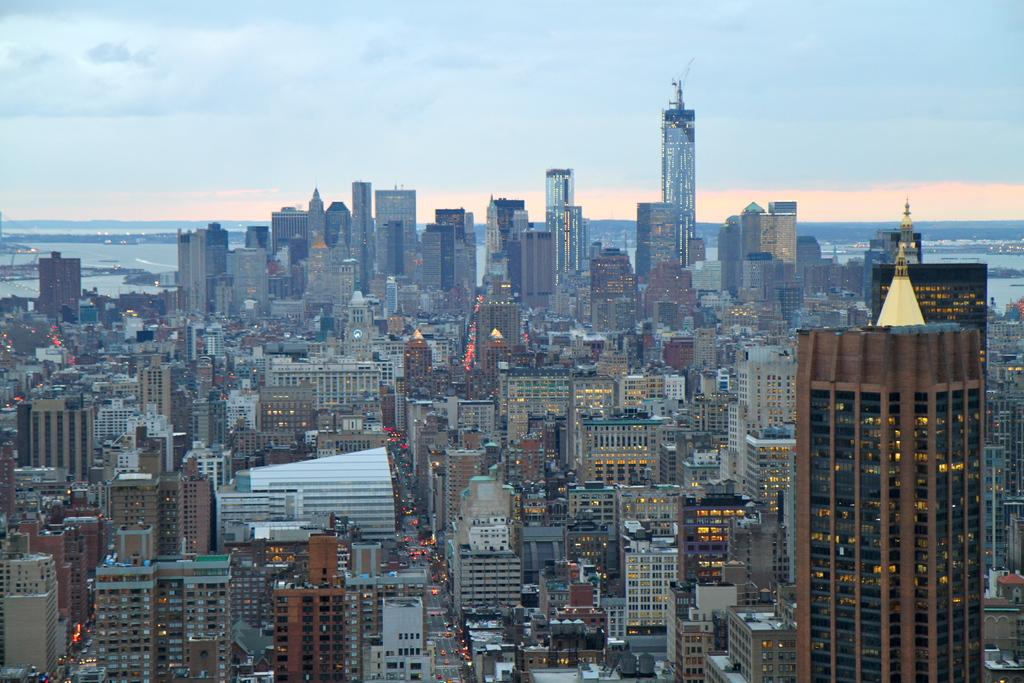What type of structures can be seen in the image? There are many buildings in the image. What natural element is visible at the back of the image? There is water visible at the back of the image. What is visible at the top of the image? The sky is visible at the top of the image. What type of apparel is being worn by the water in the image? There is no apparel present in the image, as the water is a natural element and not a person or object that can wear clothing. 